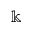Convert formula to latex. <formula><loc_0><loc_0><loc_500><loc_500>\ B b b k</formula> 